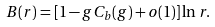<formula> <loc_0><loc_0><loc_500><loc_500>B ( r ) = [ 1 - g C _ { b } ( g ) + o ( 1 ) ] \ln r .</formula> 